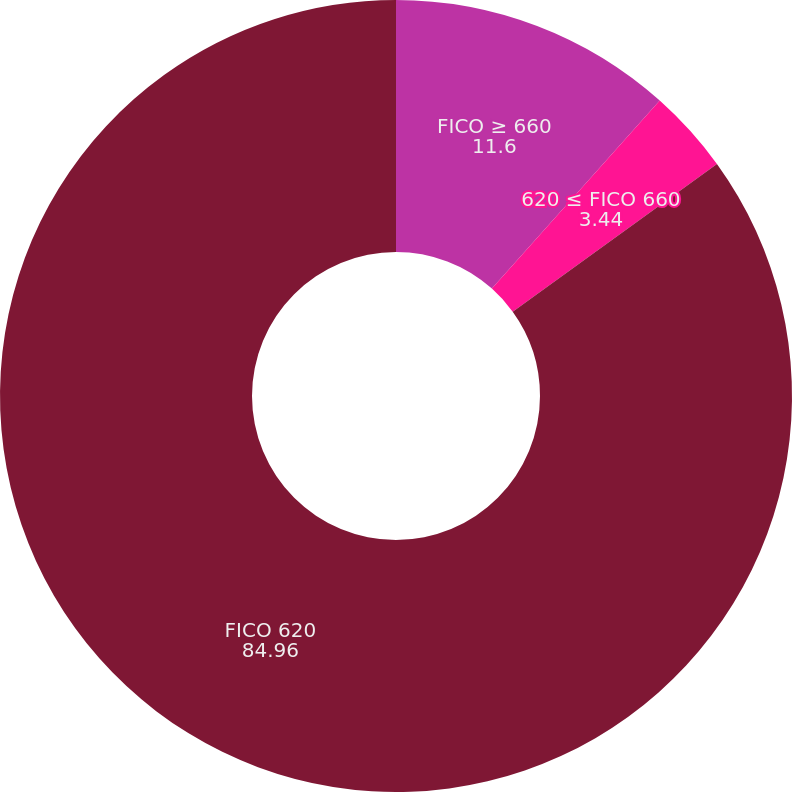Convert chart to OTSL. <chart><loc_0><loc_0><loc_500><loc_500><pie_chart><fcel>FICO ≥ 660<fcel>620 ≤ FICO 660<fcel>FICO 620<nl><fcel>11.6%<fcel>3.44%<fcel>84.96%<nl></chart> 